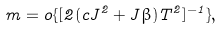Convert formula to latex. <formula><loc_0><loc_0><loc_500><loc_500>m = o \{ [ 2 ( c J ^ { 2 } + J \beta ) T ^ { 2 } ] ^ { - 1 } \} ,</formula> 